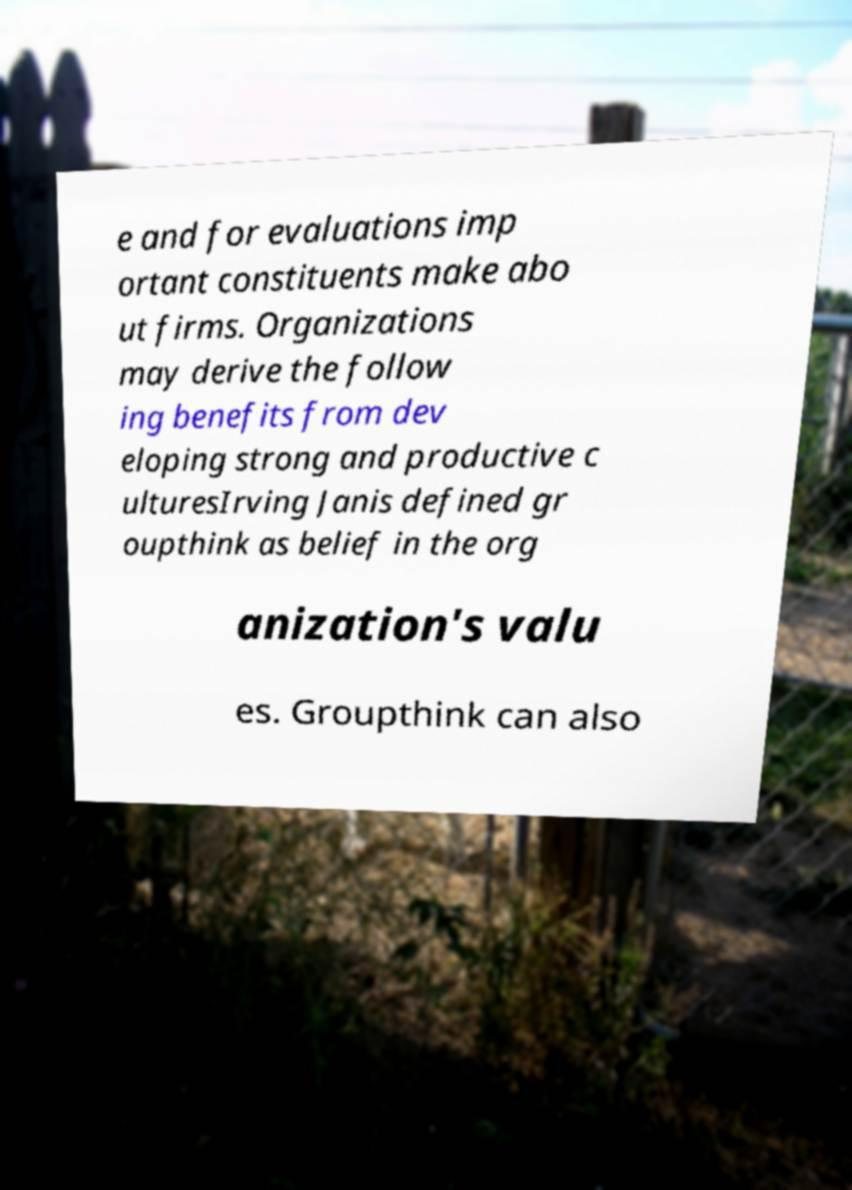Can you accurately transcribe the text from the provided image for me? e and for evaluations imp ortant constituents make abo ut firms. Organizations may derive the follow ing benefits from dev eloping strong and productive c ulturesIrving Janis defined gr oupthink as belief in the org anization's valu es. Groupthink can also 